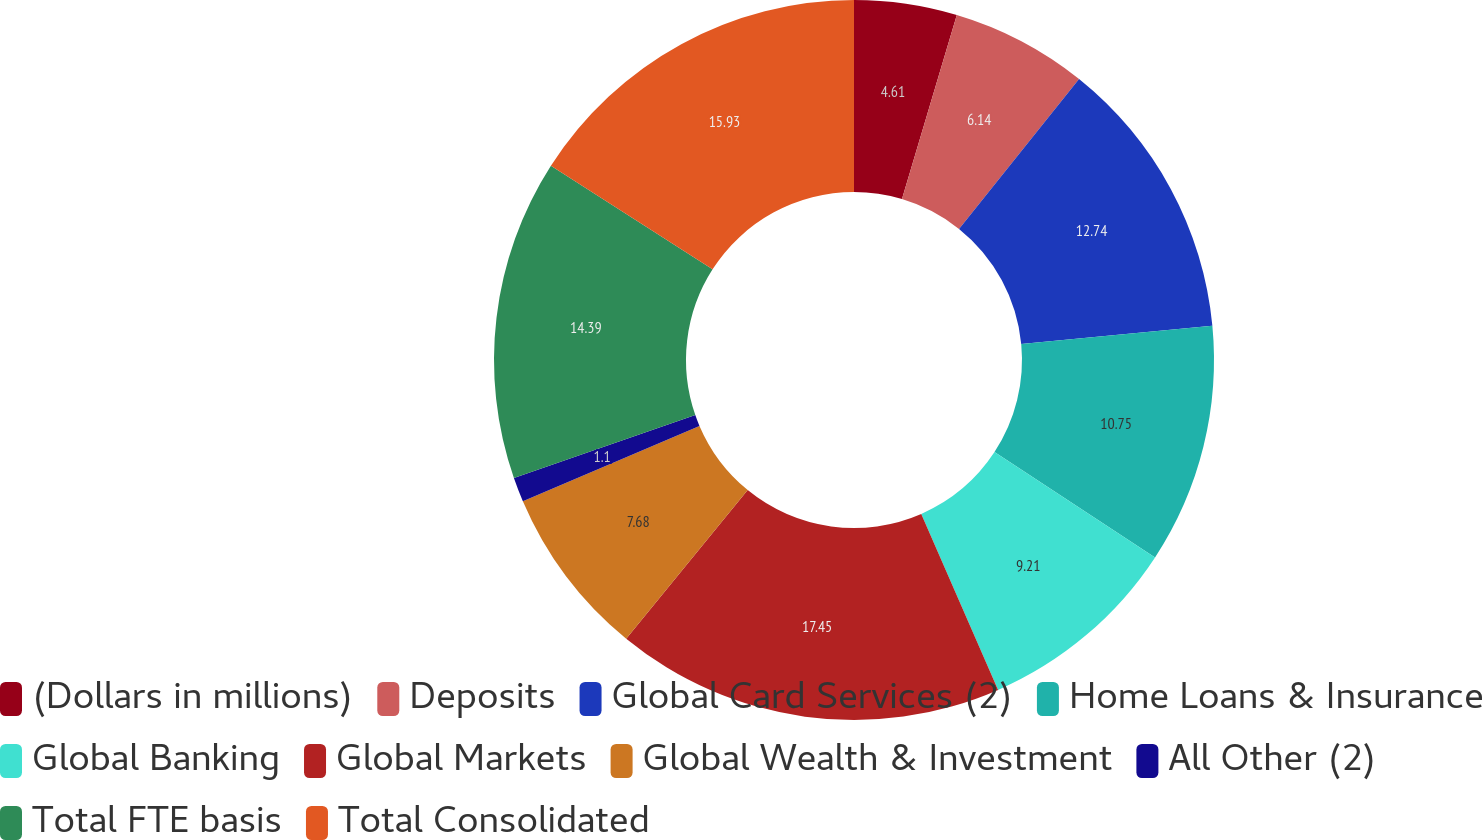Convert chart. <chart><loc_0><loc_0><loc_500><loc_500><pie_chart><fcel>(Dollars in millions)<fcel>Deposits<fcel>Global Card Services (2)<fcel>Home Loans & Insurance<fcel>Global Banking<fcel>Global Markets<fcel>Global Wealth & Investment<fcel>All Other (2)<fcel>Total FTE basis<fcel>Total Consolidated<nl><fcel>4.61%<fcel>6.14%<fcel>12.74%<fcel>10.75%<fcel>9.21%<fcel>17.46%<fcel>7.68%<fcel>1.1%<fcel>14.39%<fcel>15.93%<nl></chart> 